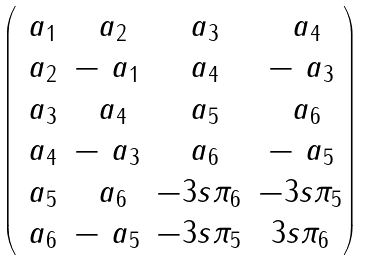<formula> <loc_0><loc_0><loc_500><loc_500>\begin{pmatrix} \ a _ { 1 } & \ a _ { 2 } & \ a _ { 3 } & \ a _ { 4 } \\ \ a _ { 2 } & - \ a _ { 1 } & \ a _ { 4 } & - \ a _ { 3 } \\ \ a _ { 3 } & \ a _ { 4 } & \ a _ { 5 } & \ a _ { 6 } \\ \ a _ { 4 } & - \ a _ { 3 } & \ a _ { 6 } & - \ a _ { 5 } \\ \ a _ { 5 } & \ a _ { 6 } & - 3 s \pi _ { 6 } & - 3 s \pi _ { 5 } \\ \ a _ { 6 } & - \ a _ { 5 } & - 3 s \pi _ { 5 } & 3 s \pi _ { 6 } \end{pmatrix}</formula> 